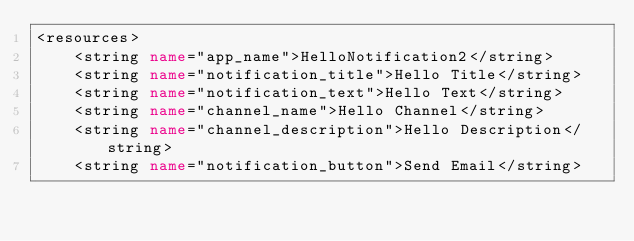<code> <loc_0><loc_0><loc_500><loc_500><_XML_><resources>
    <string name="app_name">HelloNotification2</string>
    <string name="notification_title">Hello Title</string>
    <string name="notification_text">Hello Text</string>
    <string name="channel_name">Hello Channel</string>
    <string name="channel_description">Hello Description</string>
    <string name="notification_button">Send Email</string></code> 